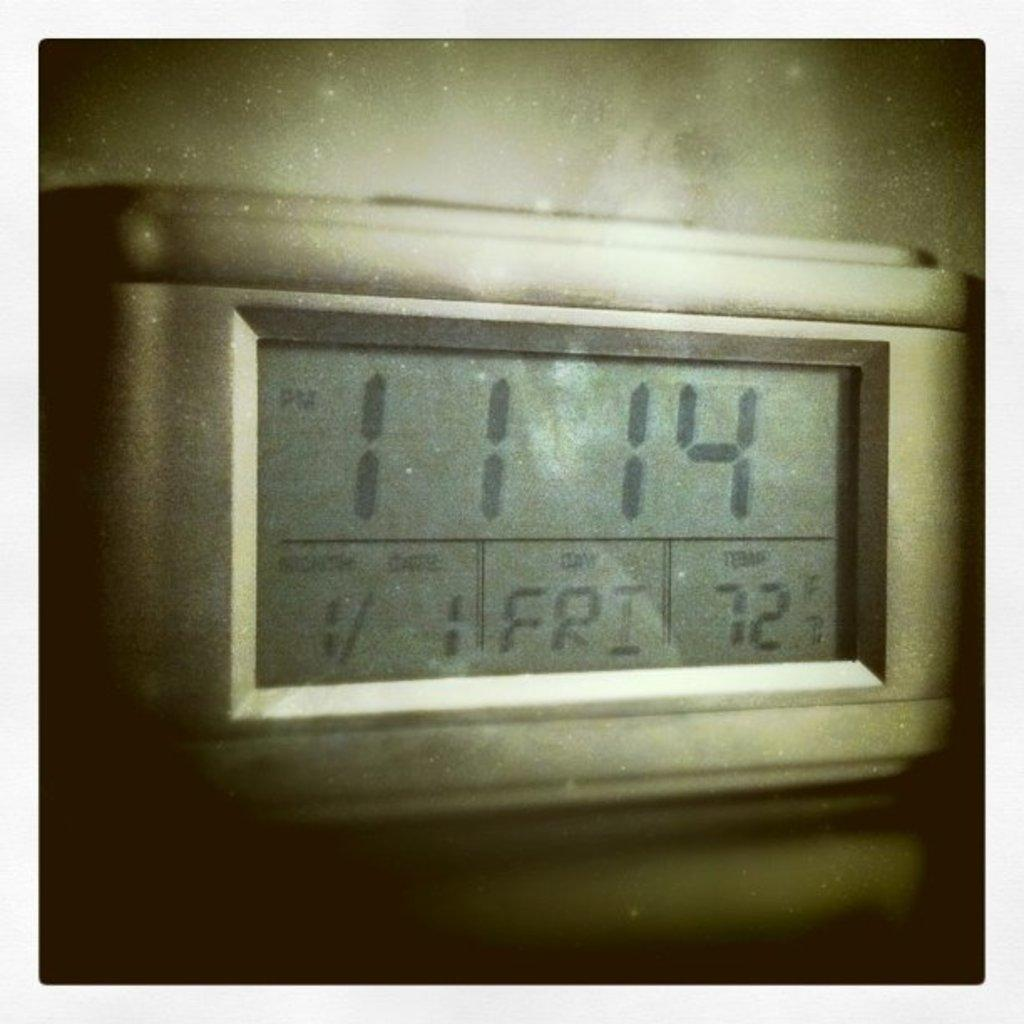<image>
Give a short and clear explanation of the subsequent image. A thermostat with the time set at 11:14 and the temperature at 72 degrees farenheit. 